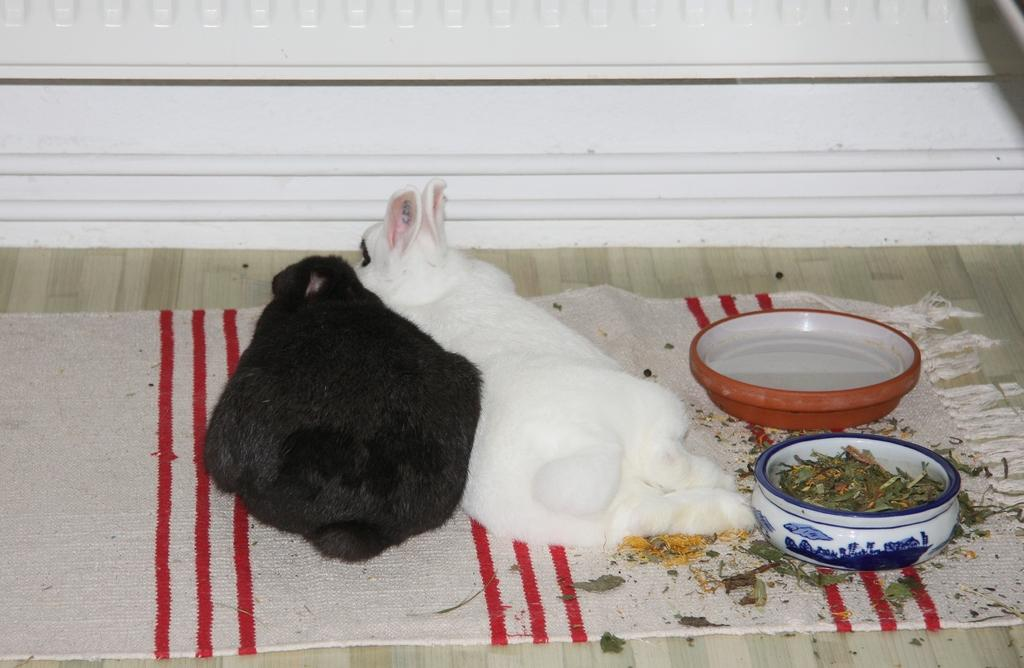What is on the floor in the image? There is a mat on the floor in the image. What is on the mat? There are rabbits and bowls on the mat. How do the rabbits help the fireman put out the fire in the image? There is no fire or fireman present in the image, and the rabbits are not depicted as helping with any fire-related tasks. 